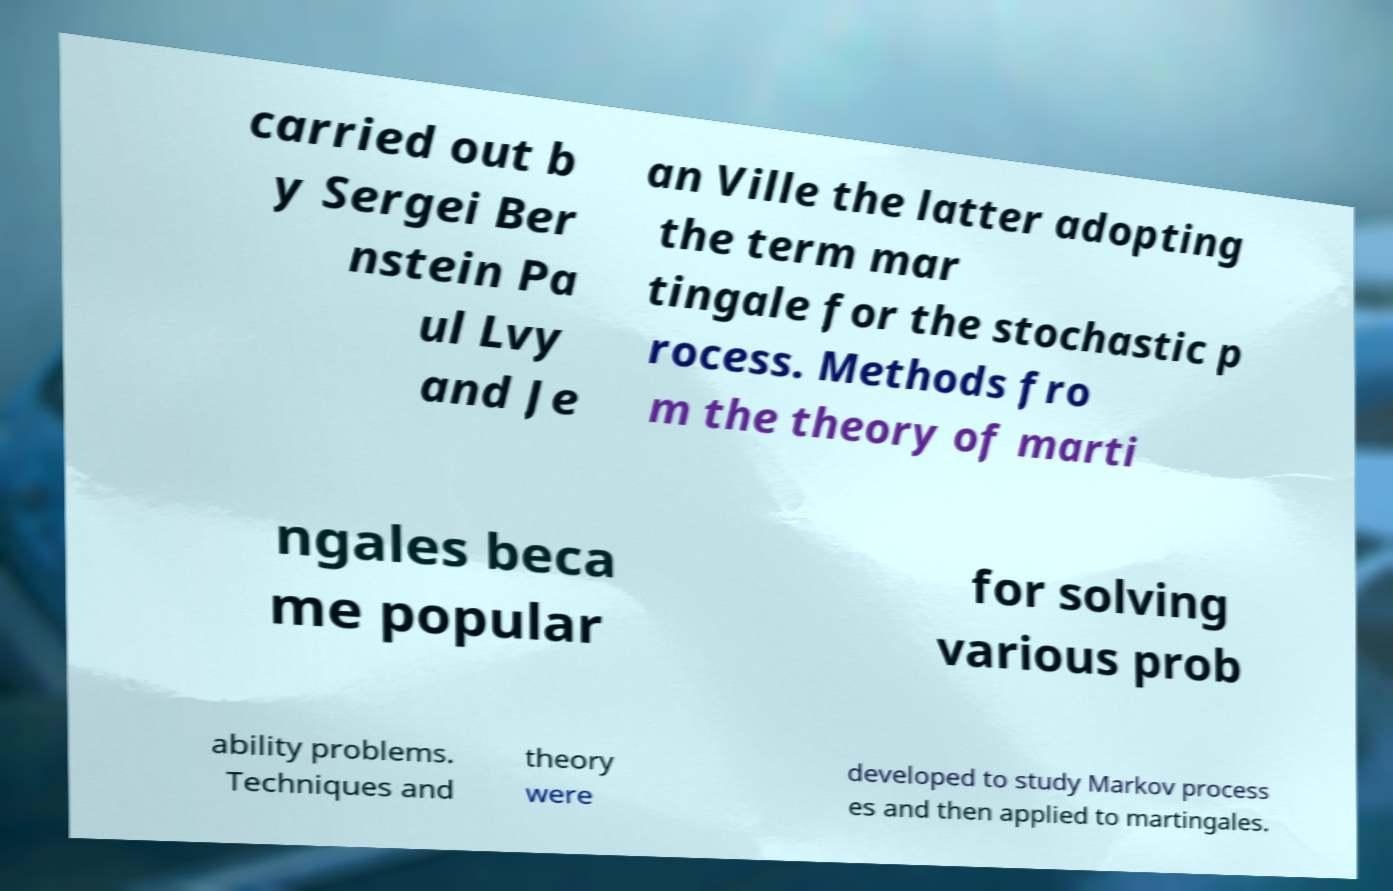For documentation purposes, I need the text within this image transcribed. Could you provide that? carried out b y Sergei Ber nstein Pa ul Lvy and Je an Ville the latter adopting the term mar tingale for the stochastic p rocess. Methods fro m the theory of marti ngales beca me popular for solving various prob ability problems. Techniques and theory were developed to study Markov process es and then applied to martingales. 